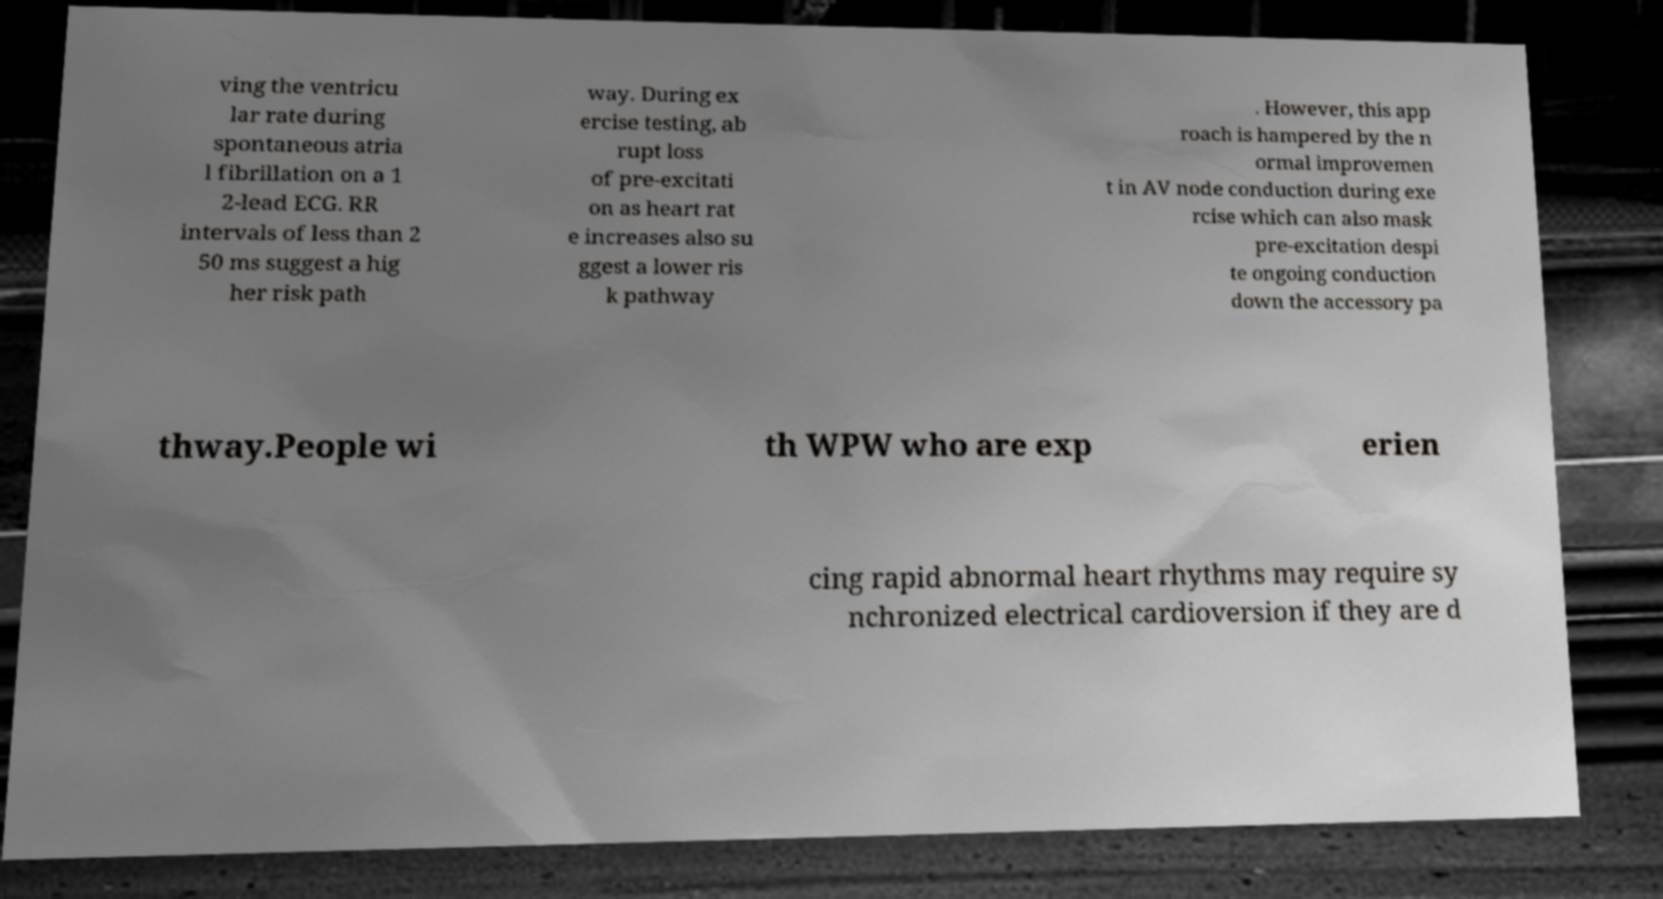Could you extract and type out the text from this image? ving the ventricu lar rate during spontaneous atria l fibrillation on a 1 2-lead ECG. RR intervals of less than 2 50 ms suggest a hig her risk path way. During ex ercise testing, ab rupt loss of pre-excitati on as heart rat e increases also su ggest a lower ris k pathway . However, this app roach is hampered by the n ormal improvemen t in AV node conduction during exe rcise which can also mask pre-excitation despi te ongoing conduction down the accessory pa thway.People wi th WPW who are exp erien cing rapid abnormal heart rhythms may require sy nchronized electrical cardioversion if they are d 